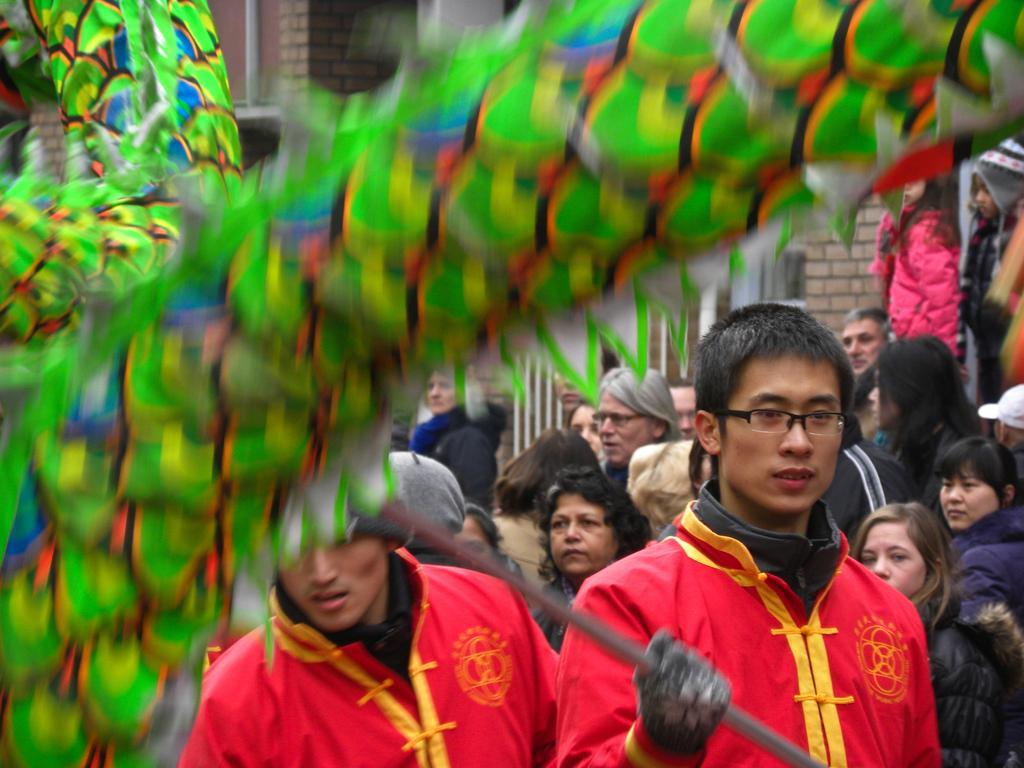In one or two sentences, can you explain what this image depicts? Here we green object and people. This person is holding a rod. Far there are brick walls. 